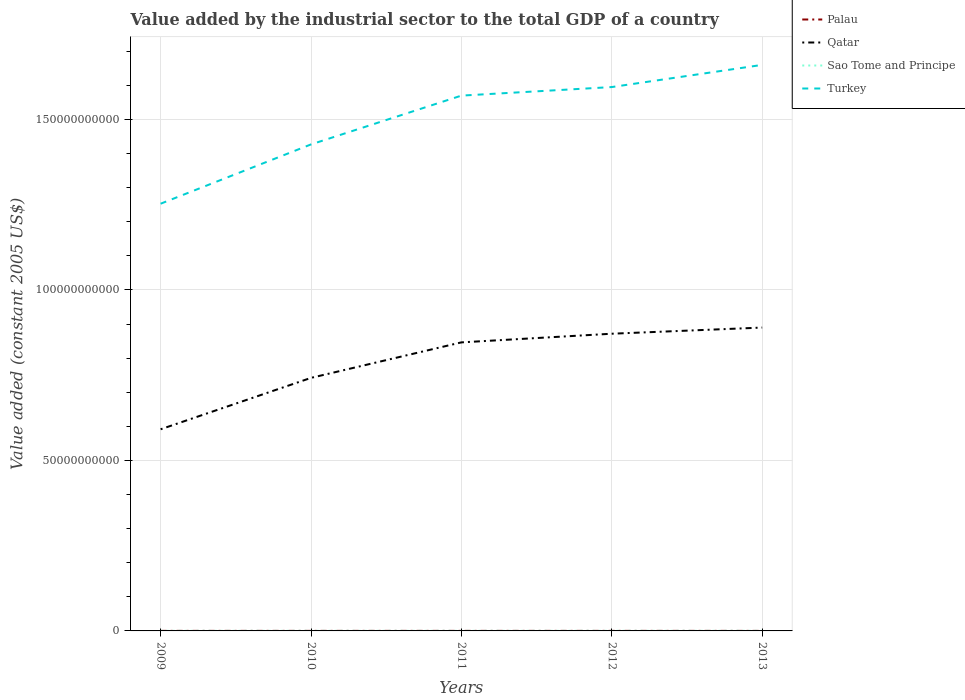Does the line corresponding to Sao Tome and Principe intersect with the line corresponding to Qatar?
Your answer should be compact. No. Is the number of lines equal to the number of legend labels?
Offer a very short reply. Yes. Across all years, what is the maximum value added by the industrial sector in Palau?
Offer a terse response. 1.09e+07. What is the total value added by the industrial sector in Qatar in the graph?
Give a very brief answer. -1.29e+1. What is the difference between the highest and the second highest value added by the industrial sector in Turkey?
Make the answer very short. 4.07e+1. What is the difference between the highest and the lowest value added by the industrial sector in Qatar?
Give a very brief answer. 3. Does the graph contain any zero values?
Your answer should be very brief. No. Where does the legend appear in the graph?
Your answer should be very brief. Top right. How many legend labels are there?
Provide a short and direct response. 4. What is the title of the graph?
Offer a terse response. Value added by the industrial sector to the total GDP of a country. Does "Malawi" appear as one of the legend labels in the graph?
Your response must be concise. No. What is the label or title of the Y-axis?
Make the answer very short. Value added (constant 2005 US$). What is the Value added (constant 2005 US$) in Palau in 2009?
Offer a very short reply. 1.25e+07. What is the Value added (constant 2005 US$) of Qatar in 2009?
Your answer should be very brief. 5.91e+1. What is the Value added (constant 2005 US$) in Sao Tome and Principe in 2009?
Ensure brevity in your answer.  2.21e+07. What is the Value added (constant 2005 US$) of Turkey in 2009?
Make the answer very short. 1.25e+11. What is the Value added (constant 2005 US$) in Palau in 2010?
Provide a short and direct response. 1.30e+07. What is the Value added (constant 2005 US$) in Qatar in 2010?
Keep it short and to the point. 7.42e+1. What is the Value added (constant 2005 US$) of Sao Tome and Principe in 2010?
Provide a short and direct response. 2.26e+07. What is the Value added (constant 2005 US$) in Turkey in 2010?
Provide a succinct answer. 1.43e+11. What is the Value added (constant 2005 US$) in Palau in 2011?
Your answer should be very brief. 1.37e+07. What is the Value added (constant 2005 US$) of Qatar in 2011?
Provide a succinct answer. 8.46e+1. What is the Value added (constant 2005 US$) in Sao Tome and Principe in 2011?
Provide a succinct answer. 2.38e+07. What is the Value added (constant 2005 US$) in Turkey in 2011?
Give a very brief answer. 1.57e+11. What is the Value added (constant 2005 US$) in Palau in 2012?
Your answer should be very brief. 1.29e+07. What is the Value added (constant 2005 US$) of Qatar in 2012?
Give a very brief answer. 8.72e+1. What is the Value added (constant 2005 US$) of Sao Tome and Principe in 2012?
Make the answer very short. 2.57e+07. What is the Value added (constant 2005 US$) in Turkey in 2012?
Your answer should be compact. 1.60e+11. What is the Value added (constant 2005 US$) of Palau in 2013?
Give a very brief answer. 1.09e+07. What is the Value added (constant 2005 US$) of Qatar in 2013?
Give a very brief answer. 8.90e+1. What is the Value added (constant 2005 US$) in Sao Tome and Principe in 2013?
Offer a terse response. 2.67e+07. What is the Value added (constant 2005 US$) in Turkey in 2013?
Offer a very short reply. 1.66e+11. Across all years, what is the maximum Value added (constant 2005 US$) in Palau?
Ensure brevity in your answer.  1.37e+07. Across all years, what is the maximum Value added (constant 2005 US$) in Qatar?
Offer a terse response. 8.90e+1. Across all years, what is the maximum Value added (constant 2005 US$) in Sao Tome and Principe?
Offer a terse response. 2.67e+07. Across all years, what is the maximum Value added (constant 2005 US$) of Turkey?
Offer a terse response. 1.66e+11. Across all years, what is the minimum Value added (constant 2005 US$) of Palau?
Ensure brevity in your answer.  1.09e+07. Across all years, what is the minimum Value added (constant 2005 US$) in Qatar?
Ensure brevity in your answer.  5.91e+1. Across all years, what is the minimum Value added (constant 2005 US$) in Sao Tome and Principe?
Provide a succinct answer. 2.21e+07. Across all years, what is the minimum Value added (constant 2005 US$) in Turkey?
Ensure brevity in your answer.  1.25e+11. What is the total Value added (constant 2005 US$) of Palau in the graph?
Provide a succinct answer. 6.30e+07. What is the total Value added (constant 2005 US$) of Qatar in the graph?
Provide a short and direct response. 3.94e+11. What is the total Value added (constant 2005 US$) in Sao Tome and Principe in the graph?
Your answer should be compact. 1.21e+08. What is the total Value added (constant 2005 US$) of Turkey in the graph?
Provide a succinct answer. 7.50e+11. What is the difference between the Value added (constant 2005 US$) of Palau in 2009 and that in 2010?
Your answer should be very brief. -4.48e+05. What is the difference between the Value added (constant 2005 US$) of Qatar in 2009 and that in 2010?
Give a very brief answer. -1.51e+1. What is the difference between the Value added (constant 2005 US$) in Sao Tome and Principe in 2009 and that in 2010?
Give a very brief answer. -5.12e+05. What is the difference between the Value added (constant 2005 US$) in Turkey in 2009 and that in 2010?
Offer a terse response. -1.74e+1. What is the difference between the Value added (constant 2005 US$) in Palau in 2009 and that in 2011?
Offer a very short reply. -1.14e+06. What is the difference between the Value added (constant 2005 US$) in Qatar in 2009 and that in 2011?
Your answer should be very brief. -2.55e+1. What is the difference between the Value added (constant 2005 US$) of Sao Tome and Principe in 2009 and that in 2011?
Provide a short and direct response. -1.72e+06. What is the difference between the Value added (constant 2005 US$) in Turkey in 2009 and that in 2011?
Make the answer very short. -3.17e+1. What is the difference between the Value added (constant 2005 US$) in Palau in 2009 and that in 2012?
Offer a terse response. -3.98e+05. What is the difference between the Value added (constant 2005 US$) in Qatar in 2009 and that in 2012?
Provide a short and direct response. -2.80e+1. What is the difference between the Value added (constant 2005 US$) of Sao Tome and Principe in 2009 and that in 2012?
Offer a terse response. -3.61e+06. What is the difference between the Value added (constant 2005 US$) in Turkey in 2009 and that in 2012?
Your response must be concise. -3.42e+1. What is the difference between the Value added (constant 2005 US$) of Palau in 2009 and that in 2013?
Give a very brief answer. 1.60e+06. What is the difference between the Value added (constant 2005 US$) in Qatar in 2009 and that in 2013?
Give a very brief answer. -2.98e+1. What is the difference between the Value added (constant 2005 US$) of Sao Tome and Principe in 2009 and that in 2013?
Your answer should be very brief. -4.63e+06. What is the difference between the Value added (constant 2005 US$) of Turkey in 2009 and that in 2013?
Ensure brevity in your answer.  -4.07e+1. What is the difference between the Value added (constant 2005 US$) of Palau in 2010 and that in 2011?
Your response must be concise. -6.92e+05. What is the difference between the Value added (constant 2005 US$) in Qatar in 2010 and that in 2011?
Provide a succinct answer. -1.04e+1. What is the difference between the Value added (constant 2005 US$) of Sao Tome and Principe in 2010 and that in 2011?
Your answer should be very brief. -1.21e+06. What is the difference between the Value added (constant 2005 US$) of Turkey in 2010 and that in 2011?
Offer a very short reply. -1.43e+1. What is the difference between the Value added (constant 2005 US$) of Palau in 2010 and that in 2012?
Provide a succinct answer. 4.99e+04. What is the difference between the Value added (constant 2005 US$) in Qatar in 2010 and that in 2012?
Provide a succinct answer. -1.29e+1. What is the difference between the Value added (constant 2005 US$) in Sao Tome and Principe in 2010 and that in 2012?
Keep it short and to the point. -3.10e+06. What is the difference between the Value added (constant 2005 US$) of Turkey in 2010 and that in 2012?
Provide a succinct answer. -1.68e+1. What is the difference between the Value added (constant 2005 US$) in Palau in 2010 and that in 2013?
Your answer should be compact. 2.05e+06. What is the difference between the Value added (constant 2005 US$) in Qatar in 2010 and that in 2013?
Give a very brief answer. -1.48e+1. What is the difference between the Value added (constant 2005 US$) of Sao Tome and Principe in 2010 and that in 2013?
Ensure brevity in your answer.  -4.11e+06. What is the difference between the Value added (constant 2005 US$) of Turkey in 2010 and that in 2013?
Make the answer very short. -2.33e+1. What is the difference between the Value added (constant 2005 US$) in Palau in 2011 and that in 2012?
Provide a short and direct response. 7.42e+05. What is the difference between the Value added (constant 2005 US$) of Qatar in 2011 and that in 2012?
Your response must be concise. -2.54e+09. What is the difference between the Value added (constant 2005 US$) of Sao Tome and Principe in 2011 and that in 2012?
Keep it short and to the point. -1.89e+06. What is the difference between the Value added (constant 2005 US$) of Turkey in 2011 and that in 2012?
Your response must be concise. -2.51e+09. What is the difference between the Value added (constant 2005 US$) in Palau in 2011 and that in 2013?
Provide a succinct answer. 2.74e+06. What is the difference between the Value added (constant 2005 US$) in Qatar in 2011 and that in 2013?
Your answer should be very brief. -4.34e+09. What is the difference between the Value added (constant 2005 US$) of Sao Tome and Principe in 2011 and that in 2013?
Offer a very short reply. -2.90e+06. What is the difference between the Value added (constant 2005 US$) in Turkey in 2011 and that in 2013?
Provide a succinct answer. -9.01e+09. What is the difference between the Value added (constant 2005 US$) in Palau in 2012 and that in 2013?
Ensure brevity in your answer.  2.00e+06. What is the difference between the Value added (constant 2005 US$) of Qatar in 2012 and that in 2013?
Provide a short and direct response. -1.81e+09. What is the difference between the Value added (constant 2005 US$) in Sao Tome and Principe in 2012 and that in 2013?
Your answer should be compact. -1.01e+06. What is the difference between the Value added (constant 2005 US$) of Turkey in 2012 and that in 2013?
Provide a succinct answer. -6.50e+09. What is the difference between the Value added (constant 2005 US$) of Palau in 2009 and the Value added (constant 2005 US$) of Qatar in 2010?
Ensure brevity in your answer.  -7.42e+1. What is the difference between the Value added (constant 2005 US$) in Palau in 2009 and the Value added (constant 2005 US$) in Sao Tome and Principe in 2010?
Offer a terse response. -1.01e+07. What is the difference between the Value added (constant 2005 US$) of Palau in 2009 and the Value added (constant 2005 US$) of Turkey in 2010?
Your response must be concise. -1.43e+11. What is the difference between the Value added (constant 2005 US$) in Qatar in 2009 and the Value added (constant 2005 US$) in Sao Tome and Principe in 2010?
Your response must be concise. 5.91e+1. What is the difference between the Value added (constant 2005 US$) of Qatar in 2009 and the Value added (constant 2005 US$) of Turkey in 2010?
Provide a succinct answer. -8.35e+1. What is the difference between the Value added (constant 2005 US$) in Sao Tome and Principe in 2009 and the Value added (constant 2005 US$) in Turkey in 2010?
Make the answer very short. -1.43e+11. What is the difference between the Value added (constant 2005 US$) of Palau in 2009 and the Value added (constant 2005 US$) of Qatar in 2011?
Provide a succinct answer. -8.46e+1. What is the difference between the Value added (constant 2005 US$) of Palau in 2009 and the Value added (constant 2005 US$) of Sao Tome and Principe in 2011?
Offer a very short reply. -1.13e+07. What is the difference between the Value added (constant 2005 US$) of Palau in 2009 and the Value added (constant 2005 US$) of Turkey in 2011?
Provide a short and direct response. -1.57e+11. What is the difference between the Value added (constant 2005 US$) in Qatar in 2009 and the Value added (constant 2005 US$) in Sao Tome and Principe in 2011?
Keep it short and to the point. 5.91e+1. What is the difference between the Value added (constant 2005 US$) in Qatar in 2009 and the Value added (constant 2005 US$) in Turkey in 2011?
Your answer should be compact. -9.79e+1. What is the difference between the Value added (constant 2005 US$) of Sao Tome and Principe in 2009 and the Value added (constant 2005 US$) of Turkey in 2011?
Provide a short and direct response. -1.57e+11. What is the difference between the Value added (constant 2005 US$) in Palau in 2009 and the Value added (constant 2005 US$) in Qatar in 2012?
Offer a very short reply. -8.72e+1. What is the difference between the Value added (constant 2005 US$) in Palau in 2009 and the Value added (constant 2005 US$) in Sao Tome and Principe in 2012?
Provide a succinct answer. -1.32e+07. What is the difference between the Value added (constant 2005 US$) in Palau in 2009 and the Value added (constant 2005 US$) in Turkey in 2012?
Make the answer very short. -1.59e+11. What is the difference between the Value added (constant 2005 US$) of Qatar in 2009 and the Value added (constant 2005 US$) of Sao Tome and Principe in 2012?
Your answer should be very brief. 5.91e+1. What is the difference between the Value added (constant 2005 US$) of Qatar in 2009 and the Value added (constant 2005 US$) of Turkey in 2012?
Your answer should be very brief. -1.00e+11. What is the difference between the Value added (constant 2005 US$) of Sao Tome and Principe in 2009 and the Value added (constant 2005 US$) of Turkey in 2012?
Your answer should be very brief. -1.59e+11. What is the difference between the Value added (constant 2005 US$) of Palau in 2009 and the Value added (constant 2005 US$) of Qatar in 2013?
Keep it short and to the point. -8.90e+1. What is the difference between the Value added (constant 2005 US$) of Palau in 2009 and the Value added (constant 2005 US$) of Sao Tome and Principe in 2013?
Ensure brevity in your answer.  -1.42e+07. What is the difference between the Value added (constant 2005 US$) in Palau in 2009 and the Value added (constant 2005 US$) in Turkey in 2013?
Offer a very short reply. -1.66e+11. What is the difference between the Value added (constant 2005 US$) of Qatar in 2009 and the Value added (constant 2005 US$) of Sao Tome and Principe in 2013?
Provide a succinct answer. 5.91e+1. What is the difference between the Value added (constant 2005 US$) in Qatar in 2009 and the Value added (constant 2005 US$) in Turkey in 2013?
Keep it short and to the point. -1.07e+11. What is the difference between the Value added (constant 2005 US$) in Sao Tome and Principe in 2009 and the Value added (constant 2005 US$) in Turkey in 2013?
Your answer should be very brief. -1.66e+11. What is the difference between the Value added (constant 2005 US$) in Palau in 2010 and the Value added (constant 2005 US$) in Qatar in 2011?
Offer a very short reply. -8.46e+1. What is the difference between the Value added (constant 2005 US$) in Palau in 2010 and the Value added (constant 2005 US$) in Sao Tome and Principe in 2011?
Ensure brevity in your answer.  -1.08e+07. What is the difference between the Value added (constant 2005 US$) in Palau in 2010 and the Value added (constant 2005 US$) in Turkey in 2011?
Make the answer very short. -1.57e+11. What is the difference between the Value added (constant 2005 US$) of Qatar in 2010 and the Value added (constant 2005 US$) of Sao Tome and Principe in 2011?
Your answer should be compact. 7.42e+1. What is the difference between the Value added (constant 2005 US$) in Qatar in 2010 and the Value added (constant 2005 US$) in Turkey in 2011?
Offer a terse response. -8.28e+1. What is the difference between the Value added (constant 2005 US$) in Sao Tome and Principe in 2010 and the Value added (constant 2005 US$) in Turkey in 2011?
Provide a short and direct response. -1.57e+11. What is the difference between the Value added (constant 2005 US$) in Palau in 2010 and the Value added (constant 2005 US$) in Qatar in 2012?
Make the answer very short. -8.72e+1. What is the difference between the Value added (constant 2005 US$) in Palau in 2010 and the Value added (constant 2005 US$) in Sao Tome and Principe in 2012?
Your answer should be very brief. -1.27e+07. What is the difference between the Value added (constant 2005 US$) of Palau in 2010 and the Value added (constant 2005 US$) of Turkey in 2012?
Make the answer very short. -1.59e+11. What is the difference between the Value added (constant 2005 US$) in Qatar in 2010 and the Value added (constant 2005 US$) in Sao Tome and Principe in 2012?
Give a very brief answer. 7.42e+1. What is the difference between the Value added (constant 2005 US$) of Qatar in 2010 and the Value added (constant 2005 US$) of Turkey in 2012?
Make the answer very short. -8.53e+1. What is the difference between the Value added (constant 2005 US$) in Sao Tome and Principe in 2010 and the Value added (constant 2005 US$) in Turkey in 2012?
Provide a succinct answer. -1.59e+11. What is the difference between the Value added (constant 2005 US$) of Palau in 2010 and the Value added (constant 2005 US$) of Qatar in 2013?
Ensure brevity in your answer.  -8.90e+1. What is the difference between the Value added (constant 2005 US$) in Palau in 2010 and the Value added (constant 2005 US$) in Sao Tome and Principe in 2013?
Your answer should be compact. -1.37e+07. What is the difference between the Value added (constant 2005 US$) in Palau in 2010 and the Value added (constant 2005 US$) in Turkey in 2013?
Make the answer very short. -1.66e+11. What is the difference between the Value added (constant 2005 US$) in Qatar in 2010 and the Value added (constant 2005 US$) in Sao Tome and Principe in 2013?
Your answer should be very brief. 7.42e+1. What is the difference between the Value added (constant 2005 US$) of Qatar in 2010 and the Value added (constant 2005 US$) of Turkey in 2013?
Give a very brief answer. -9.18e+1. What is the difference between the Value added (constant 2005 US$) of Sao Tome and Principe in 2010 and the Value added (constant 2005 US$) of Turkey in 2013?
Provide a short and direct response. -1.66e+11. What is the difference between the Value added (constant 2005 US$) in Palau in 2011 and the Value added (constant 2005 US$) in Qatar in 2012?
Keep it short and to the point. -8.72e+1. What is the difference between the Value added (constant 2005 US$) of Palau in 2011 and the Value added (constant 2005 US$) of Sao Tome and Principe in 2012?
Your answer should be very brief. -1.20e+07. What is the difference between the Value added (constant 2005 US$) in Palau in 2011 and the Value added (constant 2005 US$) in Turkey in 2012?
Make the answer very short. -1.59e+11. What is the difference between the Value added (constant 2005 US$) in Qatar in 2011 and the Value added (constant 2005 US$) in Sao Tome and Principe in 2012?
Your answer should be very brief. 8.46e+1. What is the difference between the Value added (constant 2005 US$) of Qatar in 2011 and the Value added (constant 2005 US$) of Turkey in 2012?
Your response must be concise. -7.49e+1. What is the difference between the Value added (constant 2005 US$) in Sao Tome and Principe in 2011 and the Value added (constant 2005 US$) in Turkey in 2012?
Your answer should be very brief. -1.59e+11. What is the difference between the Value added (constant 2005 US$) of Palau in 2011 and the Value added (constant 2005 US$) of Qatar in 2013?
Ensure brevity in your answer.  -8.90e+1. What is the difference between the Value added (constant 2005 US$) in Palau in 2011 and the Value added (constant 2005 US$) in Sao Tome and Principe in 2013?
Your answer should be very brief. -1.30e+07. What is the difference between the Value added (constant 2005 US$) in Palau in 2011 and the Value added (constant 2005 US$) in Turkey in 2013?
Ensure brevity in your answer.  -1.66e+11. What is the difference between the Value added (constant 2005 US$) of Qatar in 2011 and the Value added (constant 2005 US$) of Sao Tome and Principe in 2013?
Your answer should be very brief. 8.46e+1. What is the difference between the Value added (constant 2005 US$) of Qatar in 2011 and the Value added (constant 2005 US$) of Turkey in 2013?
Give a very brief answer. -8.14e+1. What is the difference between the Value added (constant 2005 US$) in Sao Tome and Principe in 2011 and the Value added (constant 2005 US$) in Turkey in 2013?
Offer a very short reply. -1.66e+11. What is the difference between the Value added (constant 2005 US$) of Palau in 2012 and the Value added (constant 2005 US$) of Qatar in 2013?
Ensure brevity in your answer.  -8.90e+1. What is the difference between the Value added (constant 2005 US$) in Palau in 2012 and the Value added (constant 2005 US$) in Sao Tome and Principe in 2013?
Give a very brief answer. -1.38e+07. What is the difference between the Value added (constant 2005 US$) of Palau in 2012 and the Value added (constant 2005 US$) of Turkey in 2013?
Your response must be concise. -1.66e+11. What is the difference between the Value added (constant 2005 US$) of Qatar in 2012 and the Value added (constant 2005 US$) of Sao Tome and Principe in 2013?
Your answer should be very brief. 8.71e+1. What is the difference between the Value added (constant 2005 US$) of Qatar in 2012 and the Value added (constant 2005 US$) of Turkey in 2013?
Your answer should be compact. -7.88e+1. What is the difference between the Value added (constant 2005 US$) of Sao Tome and Principe in 2012 and the Value added (constant 2005 US$) of Turkey in 2013?
Ensure brevity in your answer.  -1.66e+11. What is the average Value added (constant 2005 US$) in Palau per year?
Make the answer very short. 1.26e+07. What is the average Value added (constant 2005 US$) of Qatar per year?
Your answer should be compact. 7.88e+1. What is the average Value added (constant 2005 US$) in Sao Tome and Principe per year?
Your response must be concise. 2.42e+07. What is the average Value added (constant 2005 US$) of Turkey per year?
Provide a succinct answer. 1.50e+11. In the year 2009, what is the difference between the Value added (constant 2005 US$) of Palau and Value added (constant 2005 US$) of Qatar?
Offer a very short reply. -5.91e+1. In the year 2009, what is the difference between the Value added (constant 2005 US$) in Palau and Value added (constant 2005 US$) in Sao Tome and Principe?
Ensure brevity in your answer.  -9.56e+06. In the year 2009, what is the difference between the Value added (constant 2005 US$) of Palau and Value added (constant 2005 US$) of Turkey?
Provide a short and direct response. -1.25e+11. In the year 2009, what is the difference between the Value added (constant 2005 US$) of Qatar and Value added (constant 2005 US$) of Sao Tome and Principe?
Give a very brief answer. 5.91e+1. In the year 2009, what is the difference between the Value added (constant 2005 US$) of Qatar and Value added (constant 2005 US$) of Turkey?
Keep it short and to the point. -6.62e+1. In the year 2009, what is the difference between the Value added (constant 2005 US$) in Sao Tome and Principe and Value added (constant 2005 US$) in Turkey?
Offer a very short reply. -1.25e+11. In the year 2010, what is the difference between the Value added (constant 2005 US$) of Palau and Value added (constant 2005 US$) of Qatar?
Offer a very short reply. -7.42e+1. In the year 2010, what is the difference between the Value added (constant 2005 US$) of Palau and Value added (constant 2005 US$) of Sao Tome and Principe?
Make the answer very short. -9.62e+06. In the year 2010, what is the difference between the Value added (constant 2005 US$) in Palau and Value added (constant 2005 US$) in Turkey?
Give a very brief answer. -1.43e+11. In the year 2010, what is the difference between the Value added (constant 2005 US$) of Qatar and Value added (constant 2005 US$) of Sao Tome and Principe?
Your answer should be very brief. 7.42e+1. In the year 2010, what is the difference between the Value added (constant 2005 US$) in Qatar and Value added (constant 2005 US$) in Turkey?
Offer a terse response. -6.85e+1. In the year 2010, what is the difference between the Value added (constant 2005 US$) in Sao Tome and Principe and Value added (constant 2005 US$) in Turkey?
Ensure brevity in your answer.  -1.43e+11. In the year 2011, what is the difference between the Value added (constant 2005 US$) of Palau and Value added (constant 2005 US$) of Qatar?
Make the answer very short. -8.46e+1. In the year 2011, what is the difference between the Value added (constant 2005 US$) of Palau and Value added (constant 2005 US$) of Sao Tome and Principe?
Make the answer very short. -1.01e+07. In the year 2011, what is the difference between the Value added (constant 2005 US$) in Palau and Value added (constant 2005 US$) in Turkey?
Your response must be concise. -1.57e+11. In the year 2011, what is the difference between the Value added (constant 2005 US$) of Qatar and Value added (constant 2005 US$) of Sao Tome and Principe?
Give a very brief answer. 8.46e+1. In the year 2011, what is the difference between the Value added (constant 2005 US$) of Qatar and Value added (constant 2005 US$) of Turkey?
Provide a succinct answer. -7.24e+1. In the year 2011, what is the difference between the Value added (constant 2005 US$) of Sao Tome and Principe and Value added (constant 2005 US$) of Turkey?
Offer a very short reply. -1.57e+11. In the year 2012, what is the difference between the Value added (constant 2005 US$) of Palau and Value added (constant 2005 US$) of Qatar?
Your answer should be compact. -8.72e+1. In the year 2012, what is the difference between the Value added (constant 2005 US$) in Palau and Value added (constant 2005 US$) in Sao Tome and Principe?
Your answer should be compact. -1.28e+07. In the year 2012, what is the difference between the Value added (constant 2005 US$) in Palau and Value added (constant 2005 US$) in Turkey?
Your answer should be very brief. -1.59e+11. In the year 2012, what is the difference between the Value added (constant 2005 US$) of Qatar and Value added (constant 2005 US$) of Sao Tome and Principe?
Your answer should be compact. 8.71e+1. In the year 2012, what is the difference between the Value added (constant 2005 US$) of Qatar and Value added (constant 2005 US$) of Turkey?
Your response must be concise. -7.23e+1. In the year 2012, what is the difference between the Value added (constant 2005 US$) of Sao Tome and Principe and Value added (constant 2005 US$) of Turkey?
Give a very brief answer. -1.59e+11. In the year 2013, what is the difference between the Value added (constant 2005 US$) in Palau and Value added (constant 2005 US$) in Qatar?
Provide a succinct answer. -8.90e+1. In the year 2013, what is the difference between the Value added (constant 2005 US$) of Palau and Value added (constant 2005 US$) of Sao Tome and Principe?
Offer a very short reply. -1.58e+07. In the year 2013, what is the difference between the Value added (constant 2005 US$) in Palau and Value added (constant 2005 US$) in Turkey?
Your answer should be very brief. -1.66e+11. In the year 2013, what is the difference between the Value added (constant 2005 US$) of Qatar and Value added (constant 2005 US$) of Sao Tome and Principe?
Ensure brevity in your answer.  8.89e+1. In the year 2013, what is the difference between the Value added (constant 2005 US$) in Qatar and Value added (constant 2005 US$) in Turkey?
Offer a terse response. -7.70e+1. In the year 2013, what is the difference between the Value added (constant 2005 US$) of Sao Tome and Principe and Value added (constant 2005 US$) of Turkey?
Your answer should be very brief. -1.66e+11. What is the ratio of the Value added (constant 2005 US$) of Palau in 2009 to that in 2010?
Ensure brevity in your answer.  0.97. What is the ratio of the Value added (constant 2005 US$) in Qatar in 2009 to that in 2010?
Give a very brief answer. 0.8. What is the ratio of the Value added (constant 2005 US$) in Sao Tome and Principe in 2009 to that in 2010?
Your response must be concise. 0.98. What is the ratio of the Value added (constant 2005 US$) of Turkey in 2009 to that in 2010?
Give a very brief answer. 0.88. What is the ratio of the Value added (constant 2005 US$) in Palau in 2009 to that in 2011?
Make the answer very short. 0.92. What is the ratio of the Value added (constant 2005 US$) of Qatar in 2009 to that in 2011?
Your answer should be compact. 0.7. What is the ratio of the Value added (constant 2005 US$) of Sao Tome and Principe in 2009 to that in 2011?
Your answer should be very brief. 0.93. What is the ratio of the Value added (constant 2005 US$) in Turkey in 2009 to that in 2011?
Your answer should be compact. 0.8. What is the ratio of the Value added (constant 2005 US$) of Palau in 2009 to that in 2012?
Offer a terse response. 0.97. What is the ratio of the Value added (constant 2005 US$) in Qatar in 2009 to that in 2012?
Your response must be concise. 0.68. What is the ratio of the Value added (constant 2005 US$) of Sao Tome and Principe in 2009 to that in 2012?
Your answer should be compact. 0.86. What is the ratio of the Value added (constant 2005 US$) in Turkey in 2009 to that in 2012?
Provide a short and direct response. 0.79. What is the ratio of the Value added (constant 2005 US$) of Palau in 2009 to that in 2013?
Provide a short and direct response. 1.15. What is the ratio of the Value added (constant 2005 US$) in Qatar in 2009 to that in 2013?
Make the answer very short. 0.66. What is the ratio of the Value added (constant 2005 US$) in Sao Tome and Principe in 2009 to that in 2013?
Offer a terse response. 0.83. What is the ratio of the Value added (constant 2005 US$) of Turkey in 2009 to that in 2013?
Your answer should be very brief. 0.75. What is the ratio of the Value added (constant 2005 US$) of Palau in 2010 to that in 2011?
Give a very brief answer. 0.95. What is the ratio of the Value added (constant 2005 US$) in Qatar in 2010 to that in 2011?
Offer a very short reply. 0.88. What is the ratio of the Value added (constant 2005 US$) in Sao Tome and Principe in 2010 to that in 2011?
Offer a very short reply. 0.95. What is the ratio of the Value added (constant 2005 US$) in Turkey in 2010 to that in 2011?
Your answer should be very brief. 0.91. What is the ratio of the Value added (constant 2005 US$) in Qatar in 2010 to that in 2012?
Offer a very short reply. 0.85. What is the ratio of the Value added (constant 2005 US$) of Sao Tome and Principe in 2010 to that in 2012?
Your answer should be very brief. 0.88. What is the ratio of the Value added (constant 2005 US$) in Turkey in 2010 to that in 2012?
Provide a succinct answer. 0.89. What is the ratio of the Value added (constant 2005 US$) of Palau in 2010 to that in 2013?
Your answer should be very brief. 1.19. What is the ratio of the Value added (constant 2005 US$) in Qatar in 2010 to that in 2013?
Ensure brevity in your answer.  0.83. What is the ratio of the Value added (constant 2005 US$) of Sao Tome and Principe in 2010 to that in 2013?
Keep it short and to the point. 0.85. What is the ratio of the Value added (constant 2005 US$) in Turkey in 2010 to that in 2013?
Your answer should be compact. 0.86. What is the ratio of the Value added (constant 2005 US$) in Palau in 2011 to that in 2012?
Ensure brevity in your answer.  1.06. What is the ratio of the Value added (constant 2005 US$) in Qatar in 2011 to that in 2012?
Provide a short and direct response. 0.97. What is the ratio of the Value added (constant 2005 US$) in Sao Tome and Principe in 2011 to that in 2012?
Your answer should be very brief. 0.93. What is the ratio of the Value added (constant 2005 US$) of Turkey in 2011 to that in 2012?
Your response must be concise. 0.98. What is the ratio of the Value added (constant 2005 US$) of Palau in 2011 to that in 2013?
Provide a succinct answer. 1.25. What is the ratio of the Value added (constant 2005 US$) in Qatar in 2011 to that in 2013?
Offer a terse response. 0.95. What is the ratio of the Value added (constant 2005 US$) of Sao Tome and Principe in 2011 to that in 2013?
Offer a very short reply. 0.89. What is the ratio of the Value added (constant 2005 US$) in Turkey in 2011 to that in 2013?
Your answer should be compact. 0.95. What is the ratio of the Value added (constant 2005 US$) of Palau in 2012 to that in 2013?
Make the answer very short. 1.18. What is the ratio of the Value added (constant 2005 US$) of Qatar in 2012 to that in 2013?
Provide a short and direct response. 0.98. What is the ratio of the Value added (constant 2005 US$) in Sao Tome and Principe in 2012 to that in 2013?
Offer a very short reply. 0.96. What is the ratio of the Value added (constant 2005 US$) in Turkey in 2012 to that in 2013?
Ensure brevity in your answer.  0.96. What is the difference between the highest and the second highest Value added (constant 2005 US$) of Palau?
Provide a succinct answer. 6.92e+05. What is the difference between the highest and the second highest Value added (constant 2005 US$) of Qatar?
Keep it short and to the point. 1.81e+09. What is the difference between the highest and the second highest Value added (constant 2005 US$) in Sao Tome and Principe?
Offer a very short reply. 1.01e+06. What is the difference between the highest and the second highest Value added (constant 2005 US$) of Turkey?
Give a very brief answer. 6.50e+09. What is the difference between the highest and the lowest Value added (constant 2005 US$) of Palau?
Provide a succinct answer. 2.74e+06. What is the difference between the highest and the lowest Value added (constant 2005 US$) of Qatar?
Your answer should be very brief. 2.98e+1. What is the difference between the highest and the lowest Value added (constant 2005 US$) of Sao Tome and Principe?
Your answer should be very brief. 4.63e+06. What is the difference between the highest and the lowest Value added (constant 2005 US$) of Turkey?
Provide a short and direct response. 4.07e+1. 